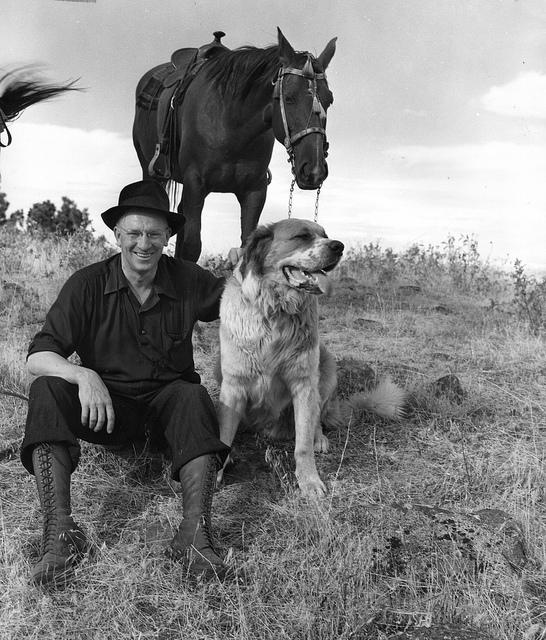Is the dog playing with anyone?
Quick response, please. No. What is the dog doing?
Be succinct. Sitting. What is behind the man?
Keep it brief. Horse. Is this a recent photo?
Write a very short answer. No. Is the horse running?
Be succinct. No. Is the man sitting?
Concise answer only. Yes. What breed of dog is this?
Be succinct. Lab. What kind of dogs is in the picture?
Quick response, please. Hound. What color is the dog's harness?
Answer briefly. Brown. 